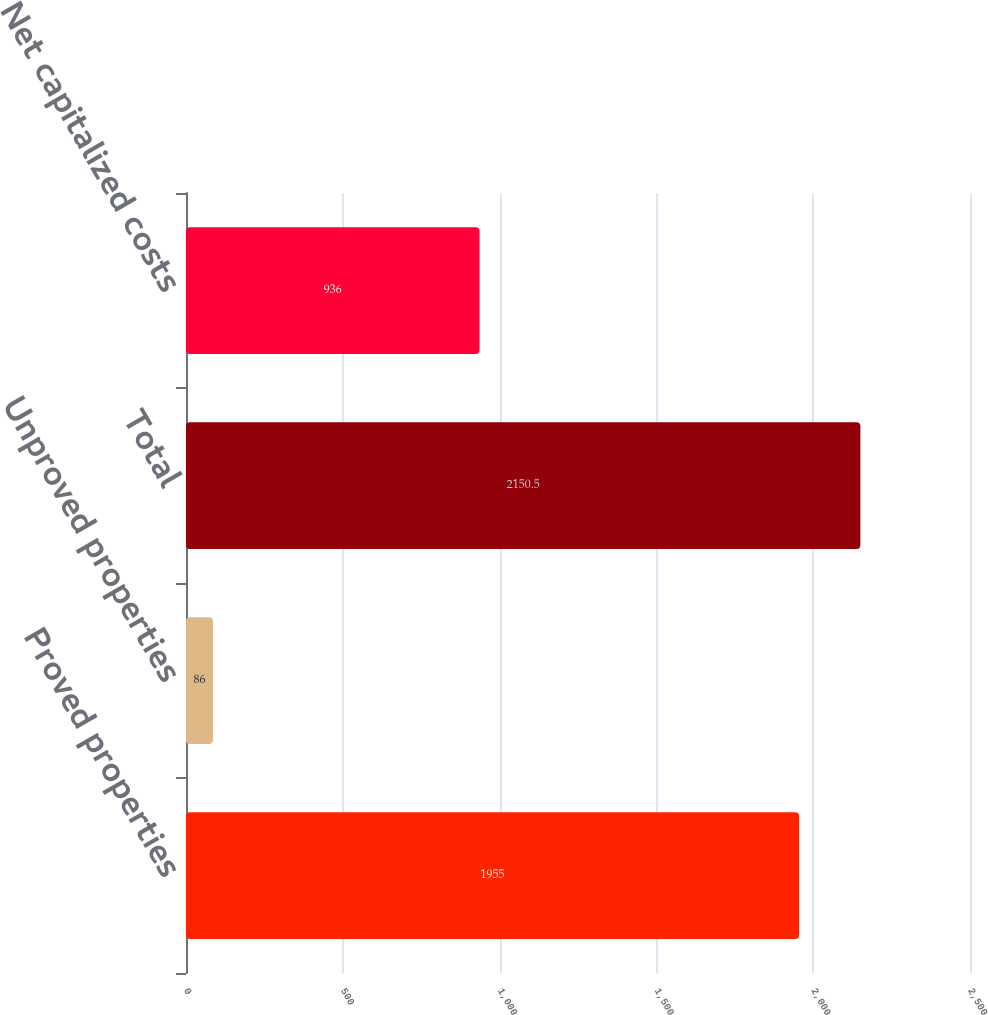<chart> <loc_0><loc_0><loc_500><loc_500><bar_chart><fcel>Proved properties<fcel>Unproved properties<fcel>Total<fcel>Net capitalized costs<nl><fcel>1955<fcel>86<fcel>2150.5<fcel>936<nl></chart> 